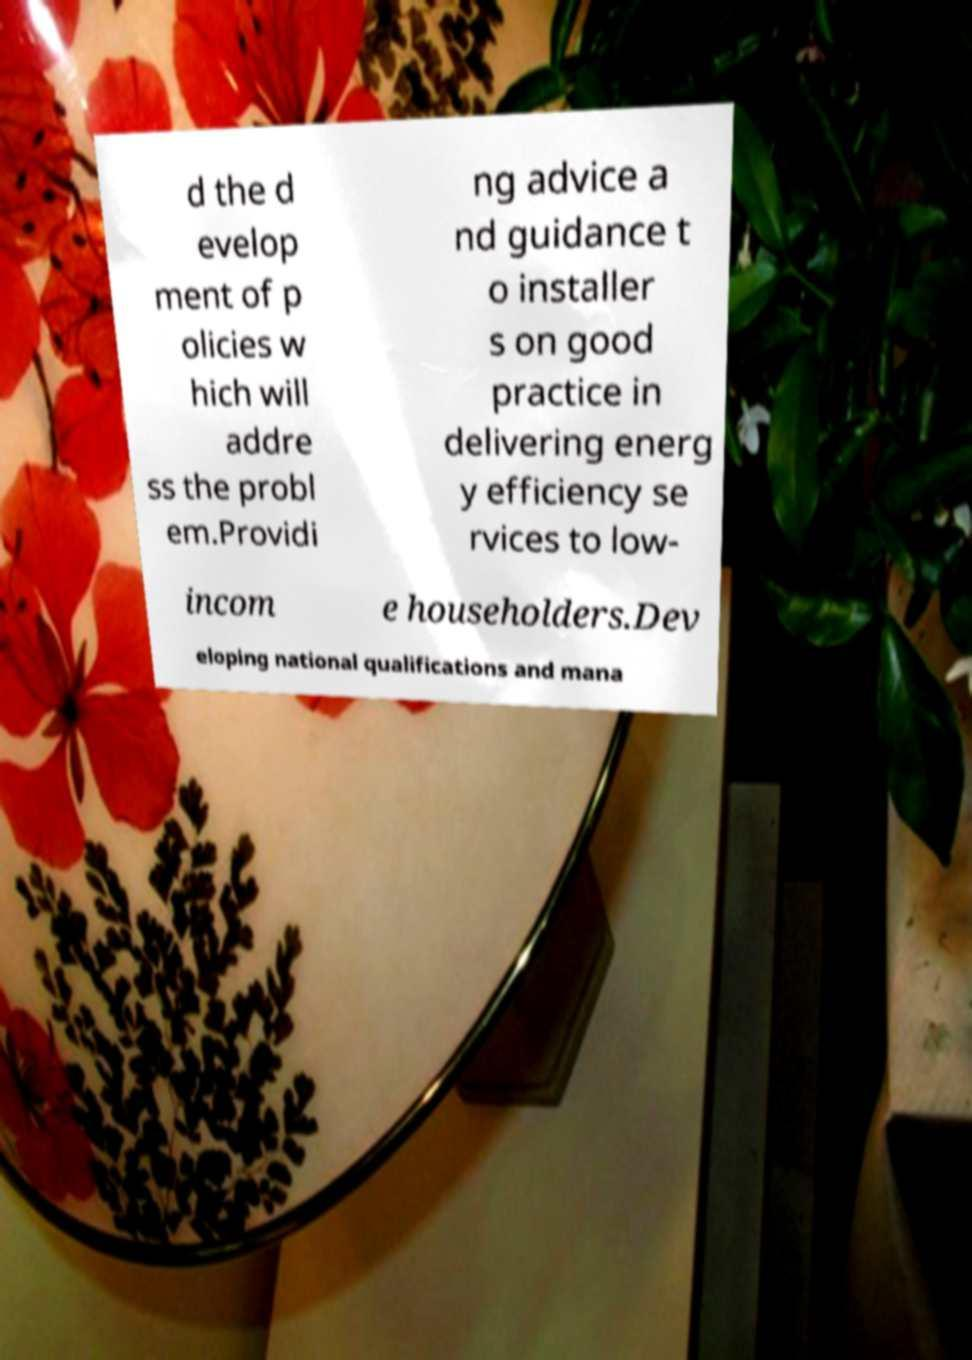Please read and relay the text visible in this image. What does it say? d the d evelop ment of p olicies w hich will addre ss the probl em.Providi ng advice a nd guidance t o installer s on good practice in delivering energ y efficiency se rvices to low- incom e householders.Dev eloping national qualifications and mana 